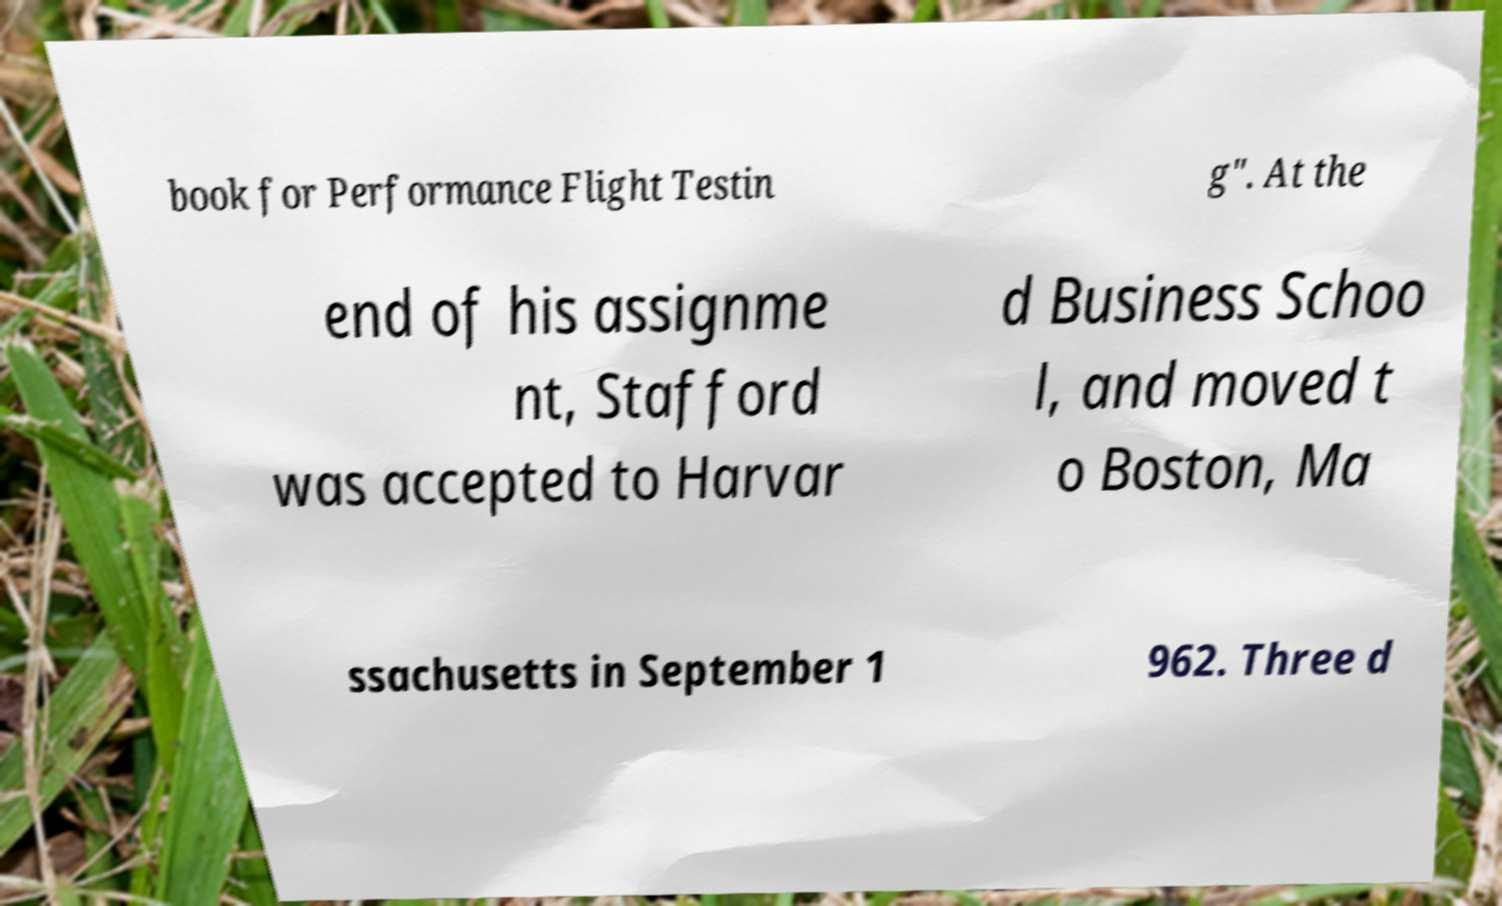Please identify and transcribe the text found in this image. book for Performance Flight Testin g". At the end of his assignme nt, Stafford was accepted to Harvar d Business Schoo l, and moved t o Boston, Ma ssachusetts in September 1 962. Three d 